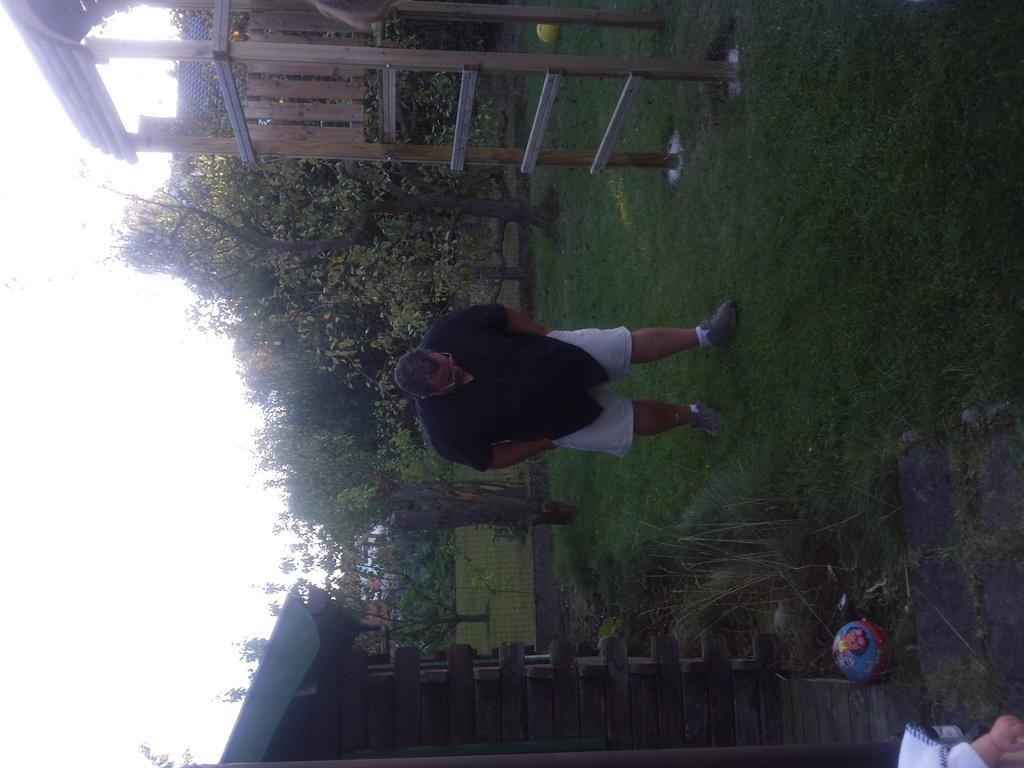What is the main subject of the image? There is a person standing in the image. What is the person wearing on their upper body? The person is wearing a black shirt. What type of pants is the person wearing? The person is wearing trousers. What can be seen in the background of the image? There are trees in the background of the image. How would you describe the weather based on the image? The sky is clear in the image, suggesting good weather. How many boys are playing with ink in the image? There are no boys or ink present in the image. Who is the expert in the image? There is no expert mentioned or depicted in the image. 